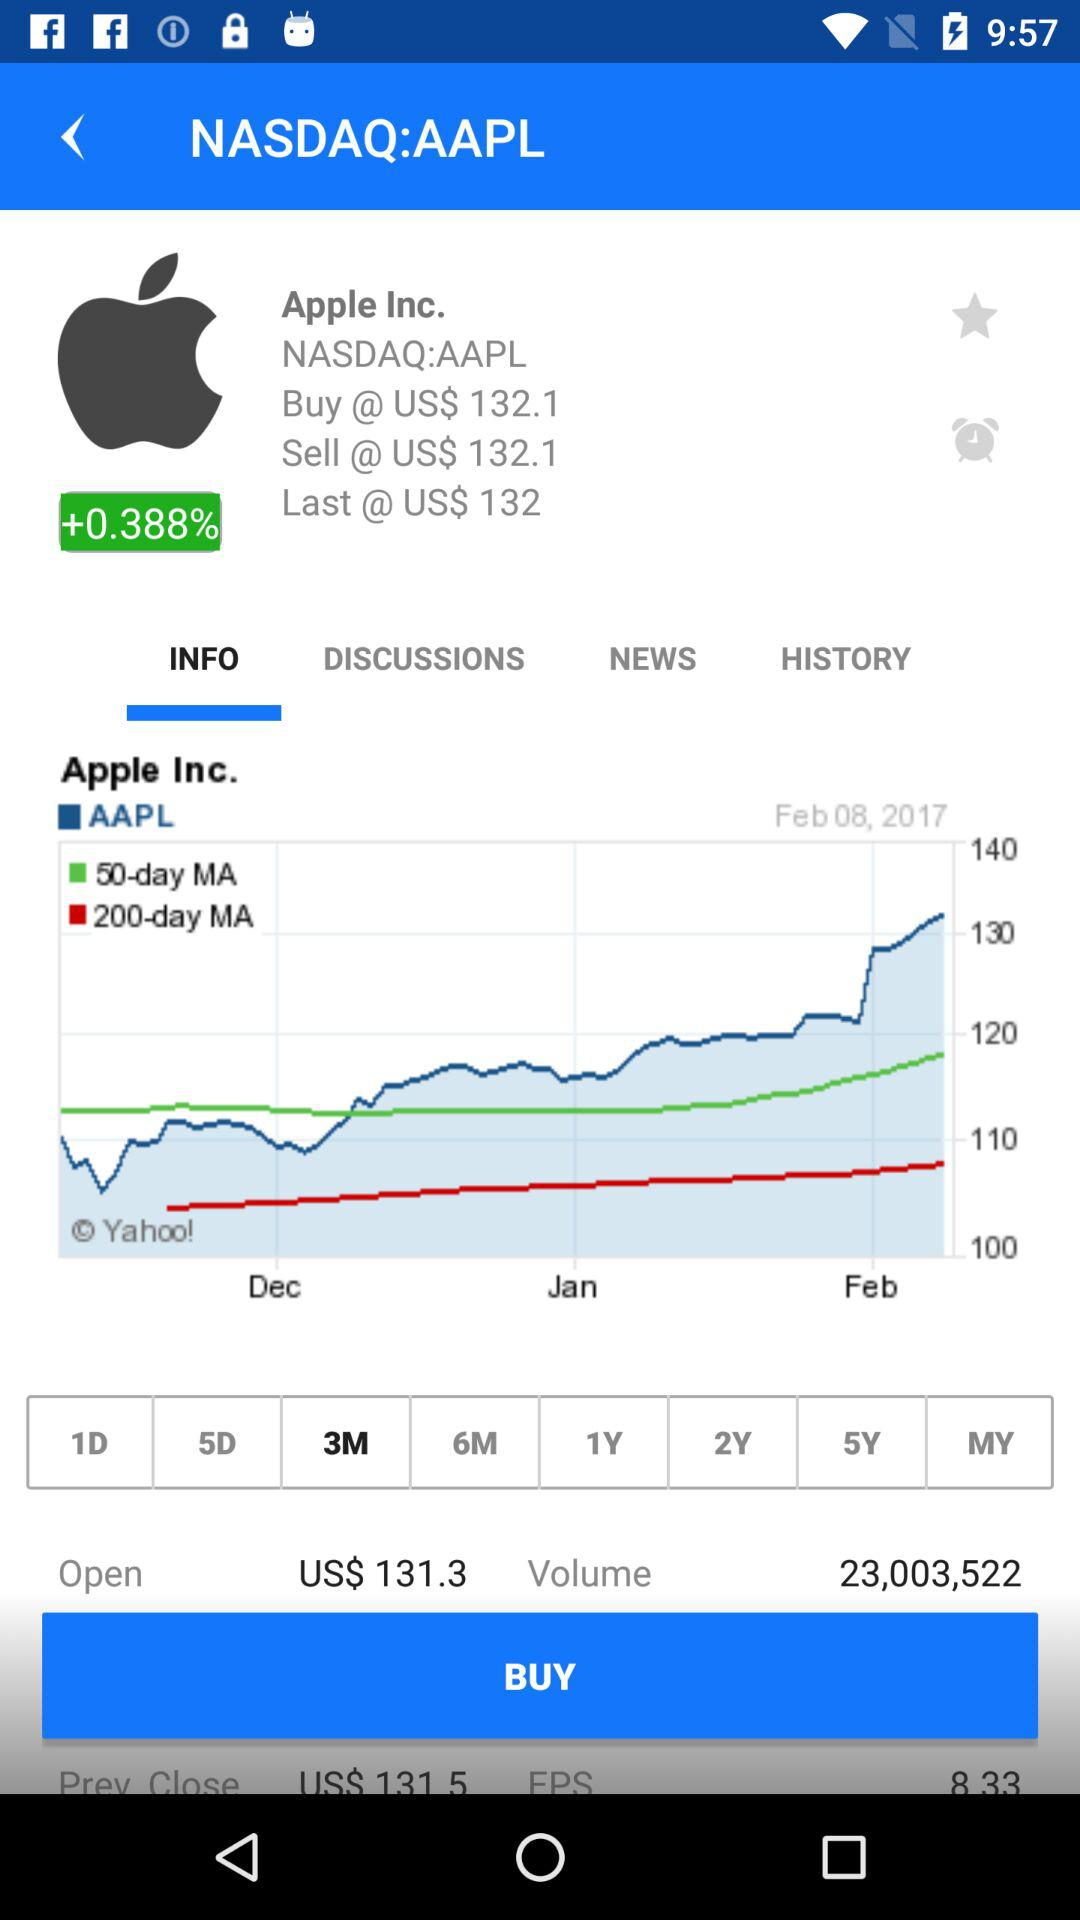What is the volume of AAPL?
Answer the question using a single word or phrase. 23,003,522 